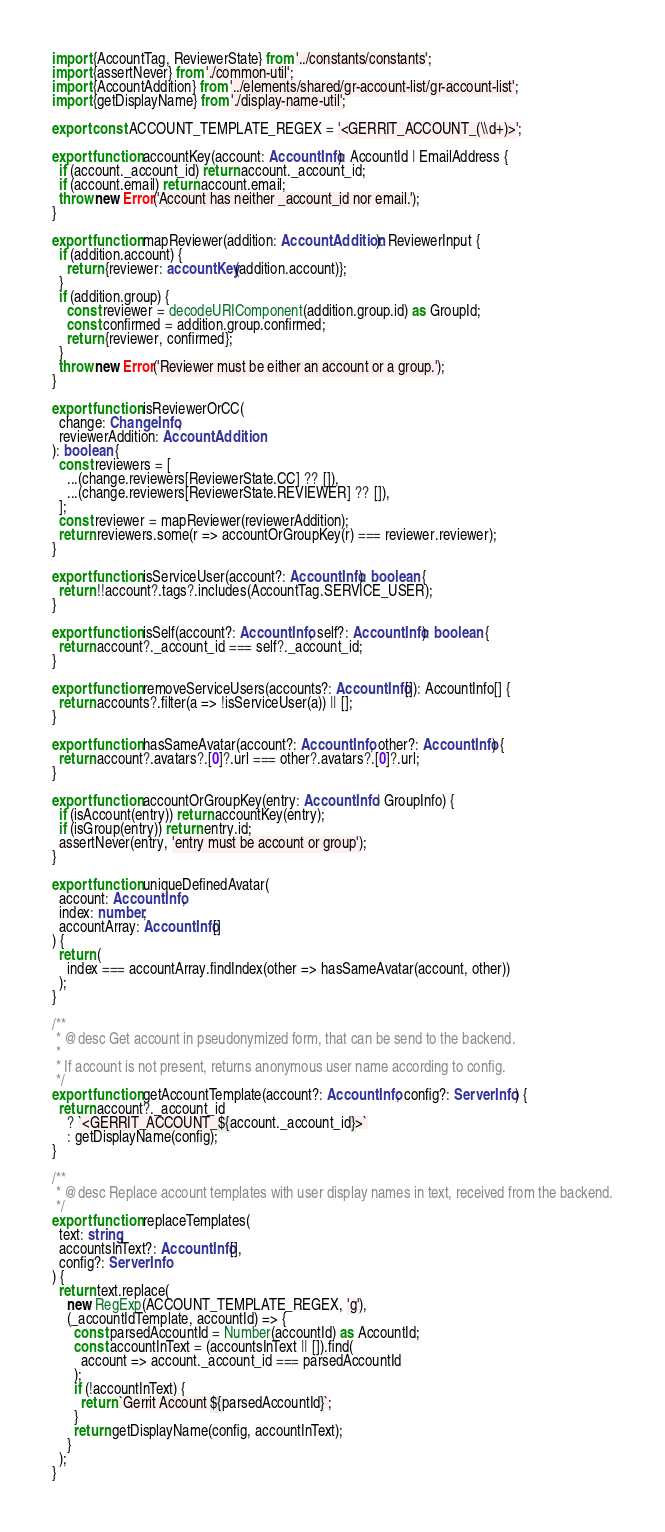<code> <loc_0><loc_0><loc_500><loc_500><_TypeScript_>import {AccountTag, ReviewerState} from '../constants/constants';
import {assertNever} from './common-util';
import {AccountAddition} from '../elements/shared/gr-account-list/gr-account-list';
import {getDisplayName} from './display-name-util';

export const ACCOUNT_TEMPLATE_REGEX = '<GERRIT_ACCOUNT_(\\d+)>';

export function accountKey(account: AccountInfo): AccountId | EmailAddress {
  if (account._account_id) return account._account_id;
  if (account.email) return account.email;
  throw new Error('Account has neither _account_id nor email.');
}

export function mapReviewer(addition: AccountAddition): ReviewerInput {
  if (addition.account) {
    return {reviewer: accountKey(addition.account)};
  }
  if (addition.group) {
    const reviewer = decodeURIComponent(addition.group.id) as GroupId;
    const confirmed = addition.group.confirmed;
    return {reviewer, confirmed};
  }
  throw new Error('Reviewer must be either an account or a group.');
}

export function isReviewerOrCC(
  change: ChangeInfo,
  reviewerAddition: AccountAddition
): boolean {
  const reviewers = [
    ...(change.reviewers[ReviewerState.CC] ?? []),
    ...(change.reviewers[ReviewerState.REVIEWER] ?? []),
  ];
  const reviewer = mapReviewer(reviewerAddition);
  return reviewers.some(r => accountOrGroupKey(r) === reviewer.reviewer);
}

export function isServiceUser(account?: AccountInfo): boolean {
  return !!account?.tags?.includes(AccountTag.SERVICE_USER);
}

export function isSelf(account?: AccountInfo, self?: AccountInfo): boolean {
  return account?._account_id === self?._account_id;
}

export function removeServiceUsers(accounts?: AccountInfo[]): AccountInfo[] {
  return accounts?.filter(a => !isServiceUser(a)) || [];
}

export function hasSameAvatar(account?: AccountInfo, other?: AccountInfo) {
  return account?.avatars?.[0]?.url === other?.avatars?.[0]?.url;
}

export function accountOrGroupKey(entry: AccountInfo | GroupInfo) {
  if (isAccount(entry)) return accountKey(entry);
  if (isGroup(entry)) return entry.id;
  assertNever(entry, 'entry must be account or group');
}

export function uniqueDefinedAvatar(
  account: AccountInfo,
  index: number,
  accountArray: AccountInfo[]
) {
  return (
    index === accountArray.findIndex(other => hasSameAvatar(account, other))
  );
}

/**
 * @desc Get account in pseudonymized form, that can be send to the backend.
 *
 * If account is not present, returns anonymous user name according to config.
 */
export function getAccountTemplate(account?: AccountInfo, config?: ServerInfo) {
  return account?._account_id
    ? `<GERRIT_ACCOUNT_${account._account_id}>`
    : getDisplayName(config);
}

/**
 * @desc Replace account templates with user display names in text, received from the backend.
 */
export function replaceTemplates(
  text: string,
  accountsInText?: AccountInfo[],
  config?: ServerInfo
) {
  return text.replace(
    new RegExp(ACCOUNT_TEMPLATE_REGEX, 'g'),
    (_accountIdTemplate, accountId) => {
      const parsedAccountId = Number(accountId) as AccountId;
      const accountInText = (accountsInText || []).find(
        account => account._account_id === parsedAccountId
      );
      if (!accountInText) {
        return `Gerrit Account ${parsedAccountId}`;
      }
      return getDisplayName(config, accountInText);
    }
  );
}
</code> 